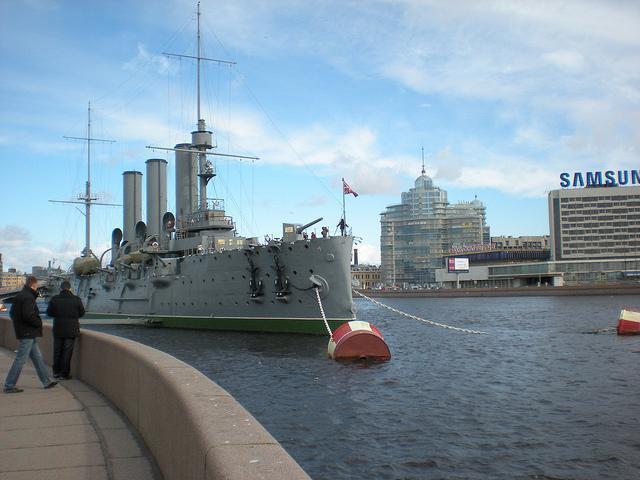How many people are seen?
Give a very brief answer. 2. How many people are there?
Give a very brief answer. 2. How many people can you see?
Give a very brief answer. 2. 